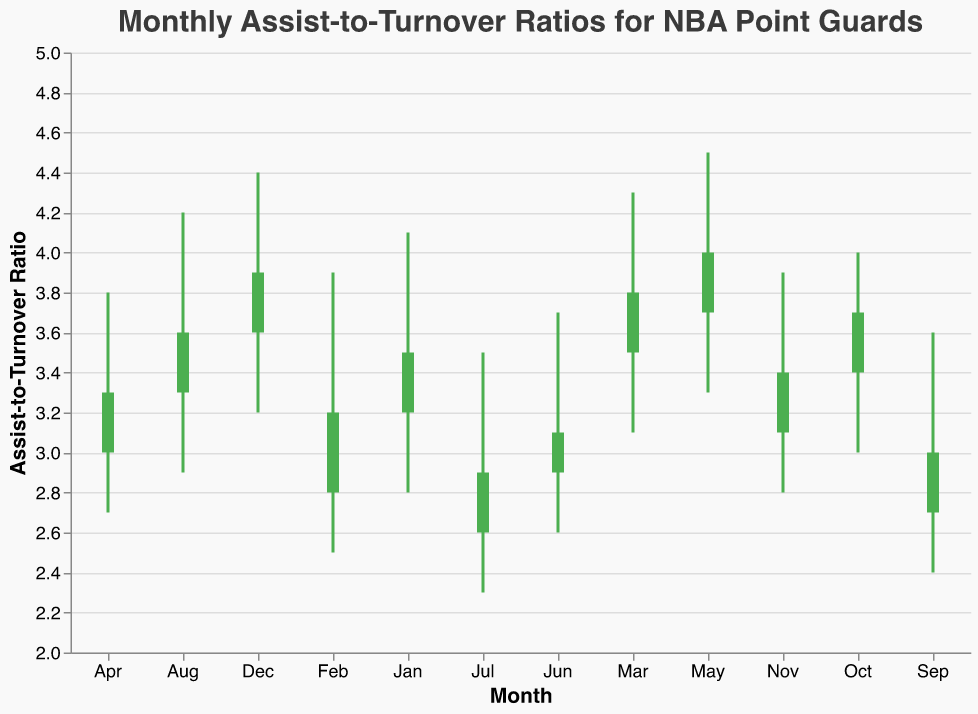What is the title of the chart? The title of the chart is displayed at the top of the figure. By looking there, we can see the text.
Answer: Monthly Assist-to-Turnover Ratios for NBA Point Guards Which player has the highest closing assist-to-turnover ratio in May? To find the player with the highest closing ratio in May, we need to look at May and find the 'Close' value for Stephen Curry.
Answer: Stephen Curry Which month shows the lowest low value? By finding the lowest 'Low' value across all months and inspecting the month associated with it, we see July has the lowest low value of 2.3.
Answer: July Which player had an increase in the assist-to-turnover ratio from the open to close value in April? By checking if the 'Close' value is greater than the 'Open' value for April, we see Luka Doncic's 'Close' value (3.3) is higher than 'Open' value (3.0).
Answer: Luka Doncic What is the difference between the High and Low values for Chris Paul in January? Calculate the difference by subtracting the 'Low' value from the 'High' value for Chris Paul in January: 4.1 - 2.8 = 1.3
Answer: 1.3 Who has the lowest opening assist-to-turnover ratio and in which month? Find the lowest "Open" value and the associated player and month by comparing all "Open" values across months. Russell Westbrook in July has the lowest opening ratio of 2.6.
Answer: Russell Westbrook, July Which months have a closing assist-to-turnover ratio greater than 3.5? Check the 'Close' values across all months and identify which ones are greater than 3.5. These months are January (Chris Paul, 3.5), March (Damian Lillard, 3.8), May (Stephen Curry, 4.0), August (Kyrie Irving, 3.6), October (Jrue Holiday, 3.7), and December (Mike Conley, 3.9).
Answer: January (Chris Paul), March (Damian Lillard), May (Stephen Curry), August (Kyrie Irving), October (Jrue Holiday), December (Mike Conley) What is the median closing assist-to-turnover ratio across all months? Arrange the 'Close' values in ascending order: 2.9, 3.0, 3.1, 3.2, 3.3, 3.4, 3.5, 3.6, 3.7, 3.8, 3.9, 4.0. With 12 data points, the median is the average of the 6th (3.4) and 7th (3.5) values: (3.4 + 3.5)/2 = 3.45
Answer: 3.45 How does Ja Morant's performance in June compare to Russell Westbrook's in July? Compare 'Open', 'High', 'Low', and 'Close' values for Ja Morant in June and Russell Westbrook in July. Ja's Open: 2.9, High: 3.7, Low: 2.6, Close: 3.1; Russell's Open: 2.6, High: 3.5, Low: 2.3, Close: 2.9. Ja Morant generally performed better in all categories.
Answer: Ja Morant performed better in all categories Which player has the most stable assist-to-turnover ratio within a month, defined by the smallest difference between High and Low values? Calculate the difference between 'High' and 'Low' for each player. Luka Doncic in April has the smallest difference: (3.8 - 2.7) = 1.1, which is less stable compared to other players.
Answer: Luka Doncic, April 